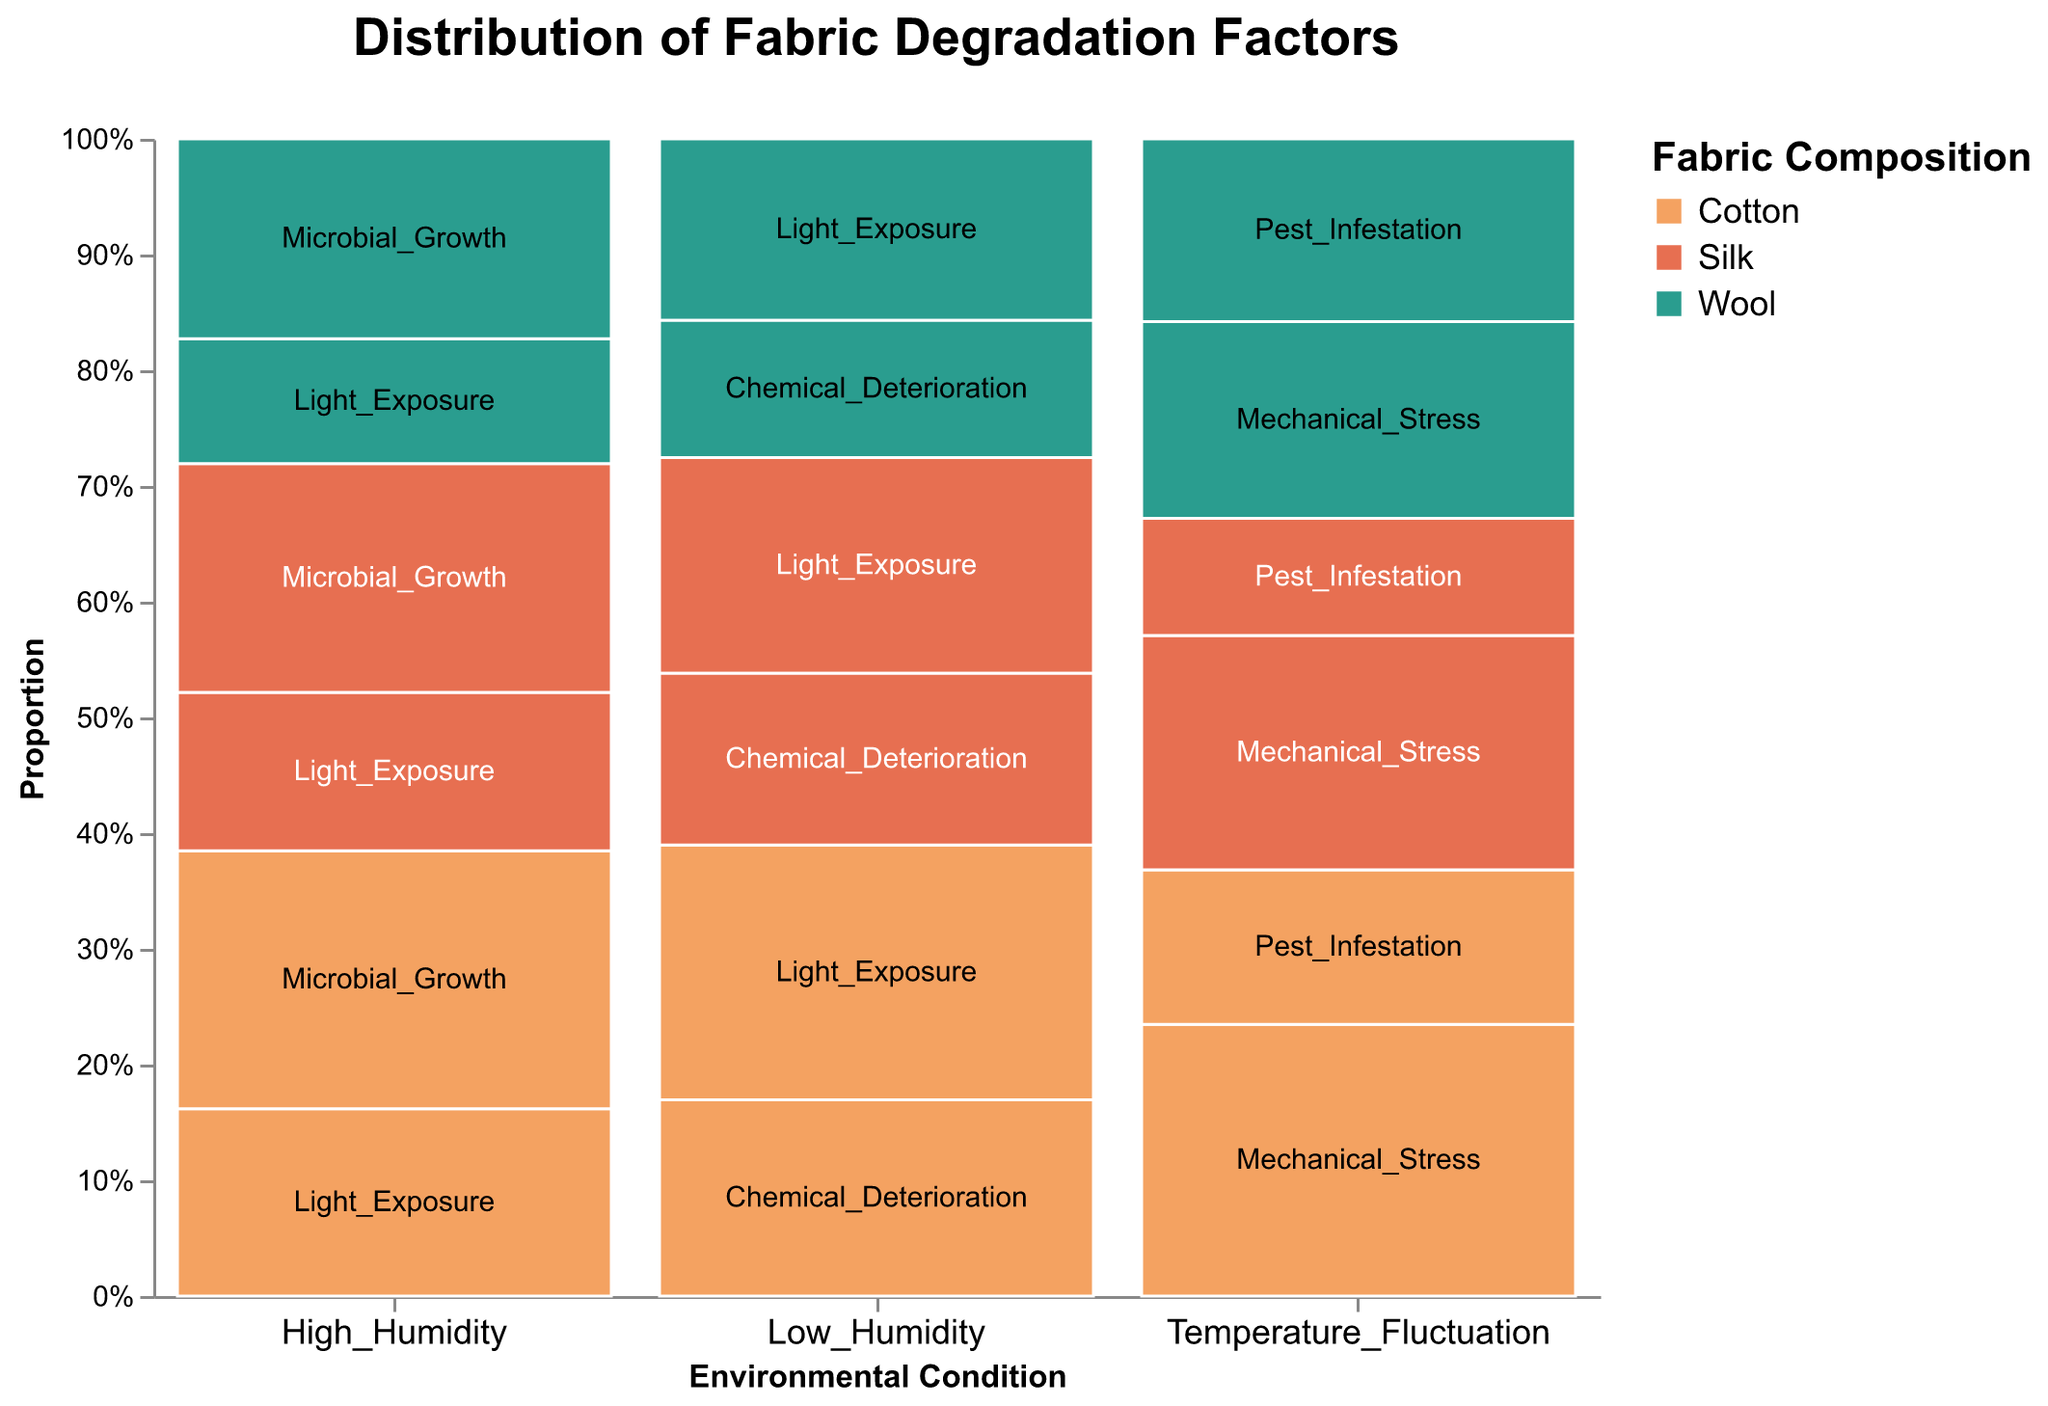What's the title of the figure? The title is prominently displayed at the top of the figure. It reads "Distribution of Fabric Degradation Factors."
Answer: Distribution of Fabric Degradation Factors What are the environmental conditions shown on the x-axis? The x-axis represents different environmental conditions, which can be identified by reading the labels along the horizontal axis. The environmental conditions are "High Humidity," "Low Humidity," and "Temperature Fluctuation."
Answer: High Humidity, Low Humidity, Temperature Fluctuation Which fabric composition is represented by the green color? Refer to the color legend to see which color corresponds to each fabric composition. The green color is associated with "Wool."
Answer: Wool Under high humidity, which degradation factor has the highest count for Cotton fabric? Look for the bars corresponding to High Humidity and Cotton. Then check the height and labels of these bars to identify the degradation factor with the highest count. "Microbial Growth" appears to have the highest count.
Answer: Microbial Growth Under low humidity, does Cotton or Silk have a higher count for Light Exposure? Look for the bars corresponding to Low Humidity and check the counts for both Cotton and Silk under Light Exposure. Cotton's Light Exposure count is higher compared to Silk's.
Answer: Cotton How do the degradation factors for Wool compare between low humidity and temperature fluctuation? Compare the heights and labels of the bars for Wool under the conditions of Low Humidity and Temperature Fluctuation. For Low Humidity, check Light Exposure and Chemical Deterioration; for Temperature Fluctuation, check Mechanical Stress and Pest Infestation. Wool shows higher counts of Mechanical Stress than any factors in Low Humidity.
Answer: Wool experiences higher degradation under temperature fluctuation compared to low humidity What is the proportion of light exposure in high humidity for Silk fabric? Locate the bar for Silk under High Humidity related to Light Exposure, then compare its height to the total height of Silk bars under High Humidity. Since high humidity for Silk has 38 counts of Light Exposure and 55 counts of Microbial Growth, the proportion for Light Exposure is 38 / (38 + 55).
Answer: 38 / (38 + 55) Which environmental condition has the greatest total degradation counts for Wool fabric? Sum the counts of all degradation factors for Wool for each environmental condition and compare which is highest. For High Humidity: (30+48), Low Humidity: (37+28), Temperature Fluctuation: (42+39). Temperature Fluctuation has the highest total.
Answer: Temperature Fluctuation What degradation factor is most common for Silk across all environmental conditions? Sum up the counts for each degradation factor for Silk across all conditions and see which has the highest total. Light Exposure: (38+44), Microbial Growth: (55), Chemical Deterioration: (35), Mechanical Stress: (50), Pest Infestation: (25). The most common is Microbial Growth.
Answer: Microbial Growth For Cotton, which environmental condition results in the highest total degradation count? Add the counts for each degradation factor for Cotton under each environmental condition. High Humidity: (45+62), Low Humidity: (52+40), Temperature Fluctuation: (58+33). High Humidity has the highest total.
Answer: High Humidity 